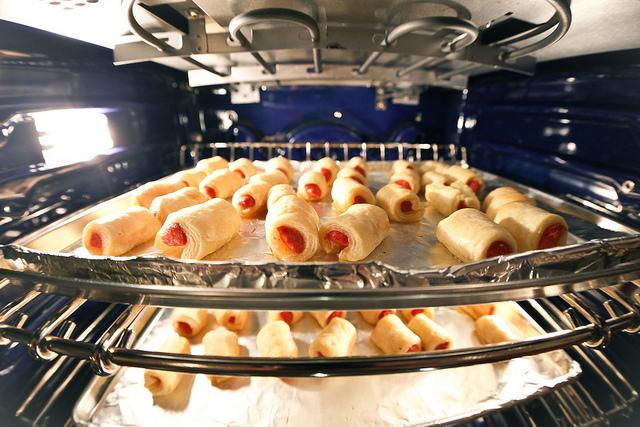Is the food ready?
Concise answer only. No. How many racks are in the oven?
Keep it brief. 2. How many pigs in blankets?
Be succinct. 43. 